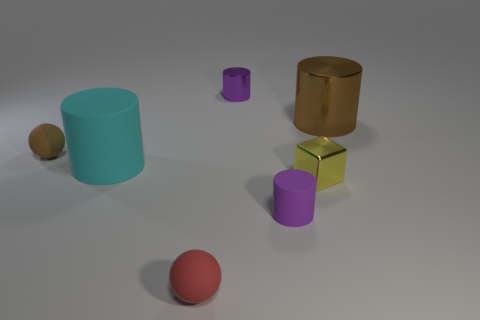Subtract all brown cylinders. How many cylinders are left? 3 Subtract all red cylinders. Subtract all green spheres. How many cylinders are left? 4 Add 3 small purple rubber cylinders. How many objects exist? 10 Subtract all cylinders. How many objects are left? 3 Subtract all tiny brown metallic things. Subtract all metal objects. How many objects are left? 4 Add 5 tiny brown spheres. How many tiny brown spheres are left? 6 Add 5 tiny blocks. How many tiny blocks exist? 6 Subtract 1 yellow cubes. How many objects are left? 6 